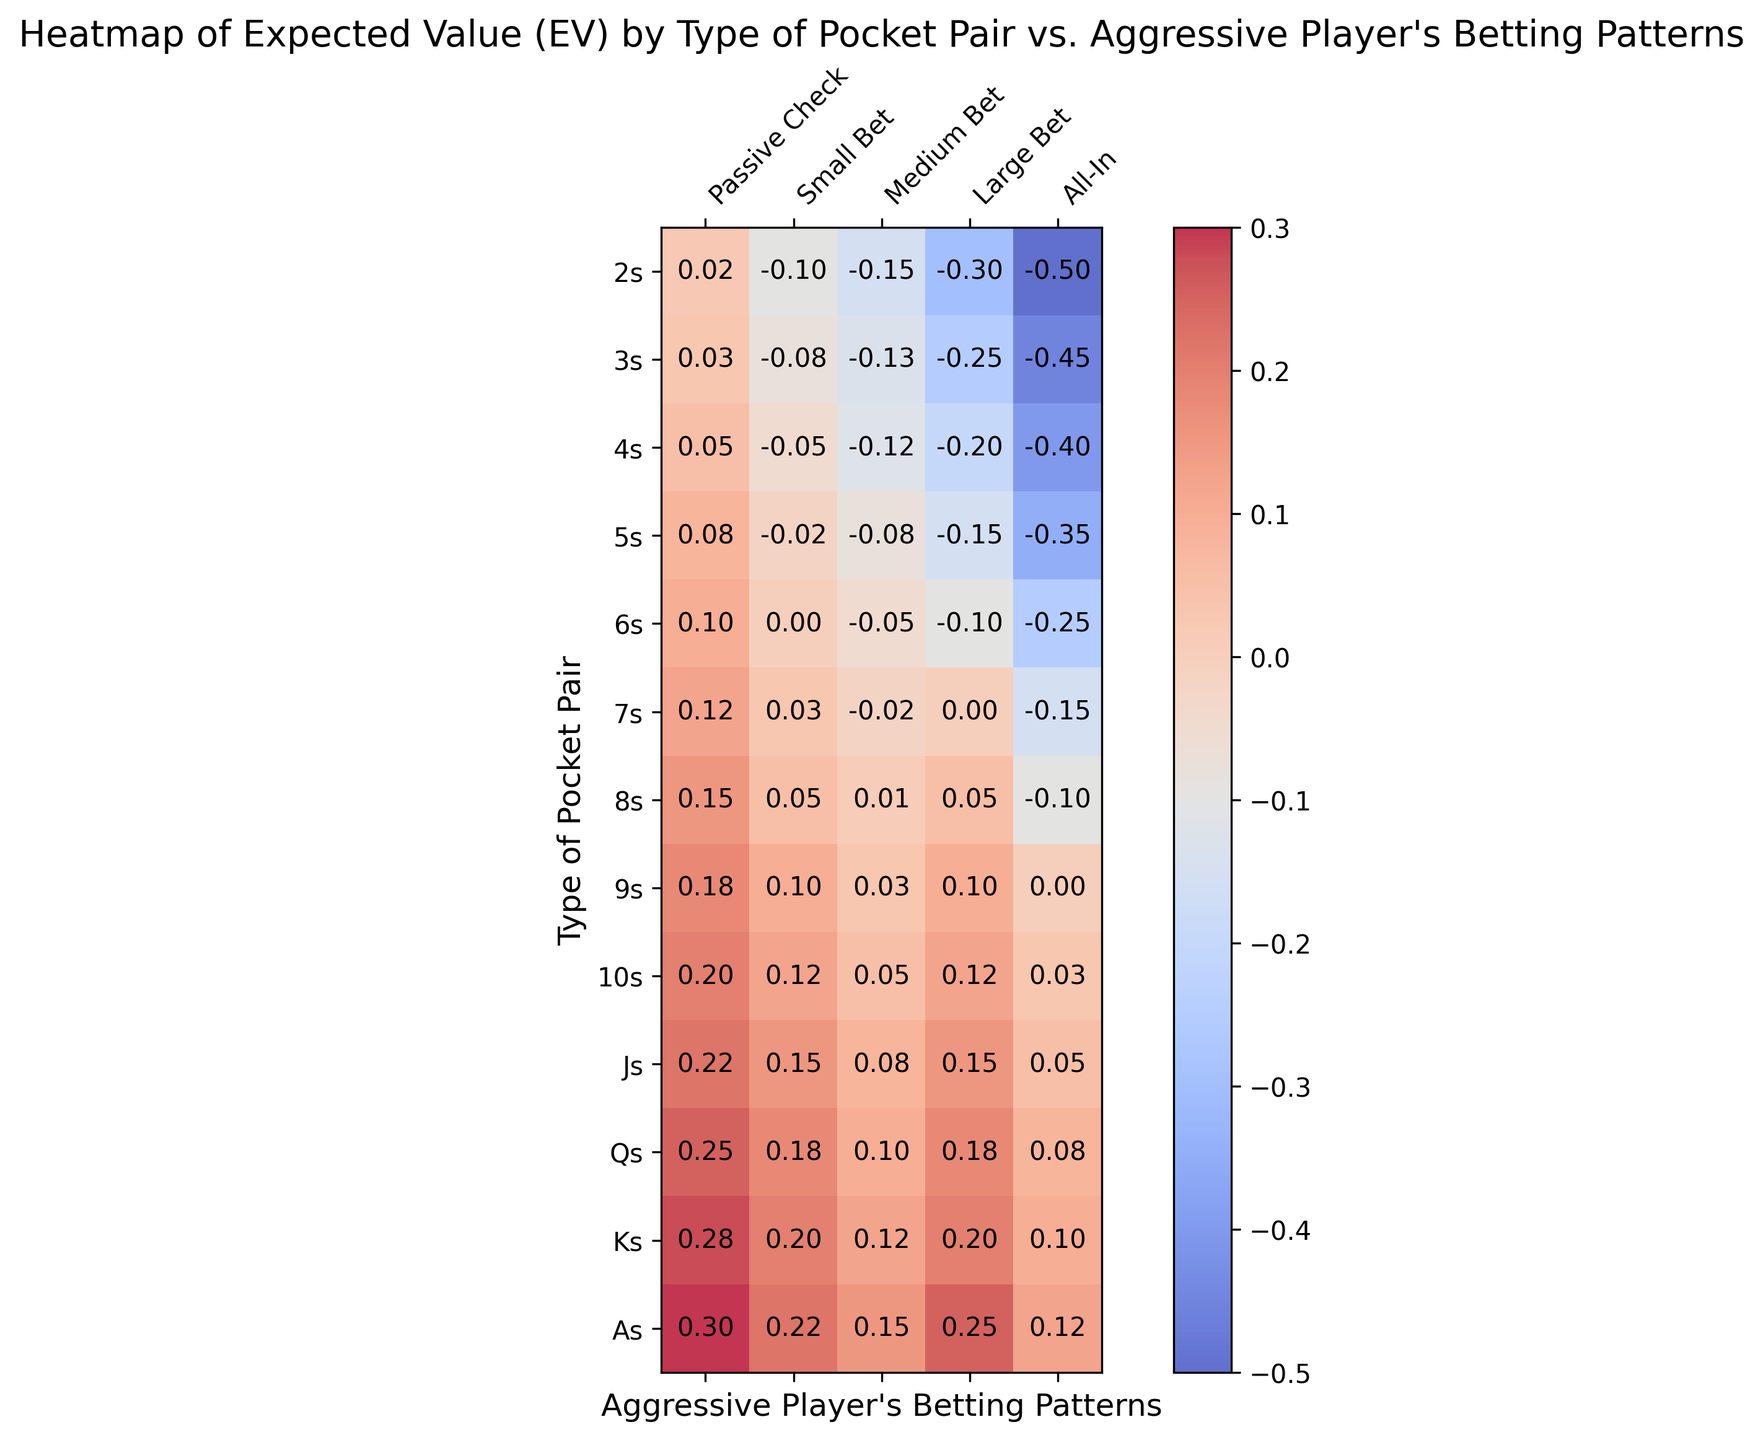What's the EV for a pair of 7s against a Medium Bet? Locate the cell corresponding to the pair of 7s and the column for Medium Bet. The value is -0.02.
Answer: -0.02 Which pocket pair has the highest EV for a Passive Check? Identify the highest value in the Passive Check column and the corresponding pocket pair. The highest value is 0.30, which is for pocket Aces (As).
Answer: As (Aces) How does the EV of a pair of 5s compare between a Small Bet and a Large Bet? Find the EV for a pair of 5s under Small Bet (-0.02) and Large Bet (-0.15). Compare the two values by calculating their difference (-0.02 - (-0.15) = 0.13).
Answer: EV for Small Bet is higher by 0.13 What is the overall trend in EV as the pocket pair gets stronger for an All-In bet? Observe the All-In column and see if the EV increases or decreases as we move from 2s to As. The values generally go from negative to less negative, indicating an increasing trend.
Answer: Increases For which type of betting pattern does a pair of Kings (Ks) reach its highest EV? Look across the row for Kings (Ks) and identify the column with the highest value. The highest EV is 0.28, which occurs with a Passive Check.
Answer: Passive Check What’s the difference in EV between a pair of 9s and a pair of Qs for an All-In bet? Find the EV for a pair of 9s and Qs under the All-In column: 0.00 for 9s and 0.08 for Qs. Subtract the values (0.08 - 0.00).
Answer: 0.08 Which pocket pair has the lowest EV for a Large Bet, and what is the value? Scan the Large Bet column and find the minimum value. The lowest value is -0.30 for a pair of 2s.
Answer: 2s, -0.30 Based on the heatmap, how does the aggressiveness of betting affect the EV for a pair of Jacks (Js)? Examine the EV values for Js across different betting patterns. Generally, the EV decreases from Passive Check (0.22) to All-In (0.05), indicating that more aggressive betting results in lower EV.
Answer: Decreases with aggressiveness What's the average EV of a pair of 8s for Passive Check and Small Bet combined? Calculate the average of the values for a pair of 8s under Passive Check (0.15) and Small Bet (0.05): (0.15 + 0.05) / 2.
Answer: 0.10 